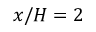Convert formula to latex. <formula><loc_0><loc_0><loc_500><loc_500>x / H = 2</formula> 